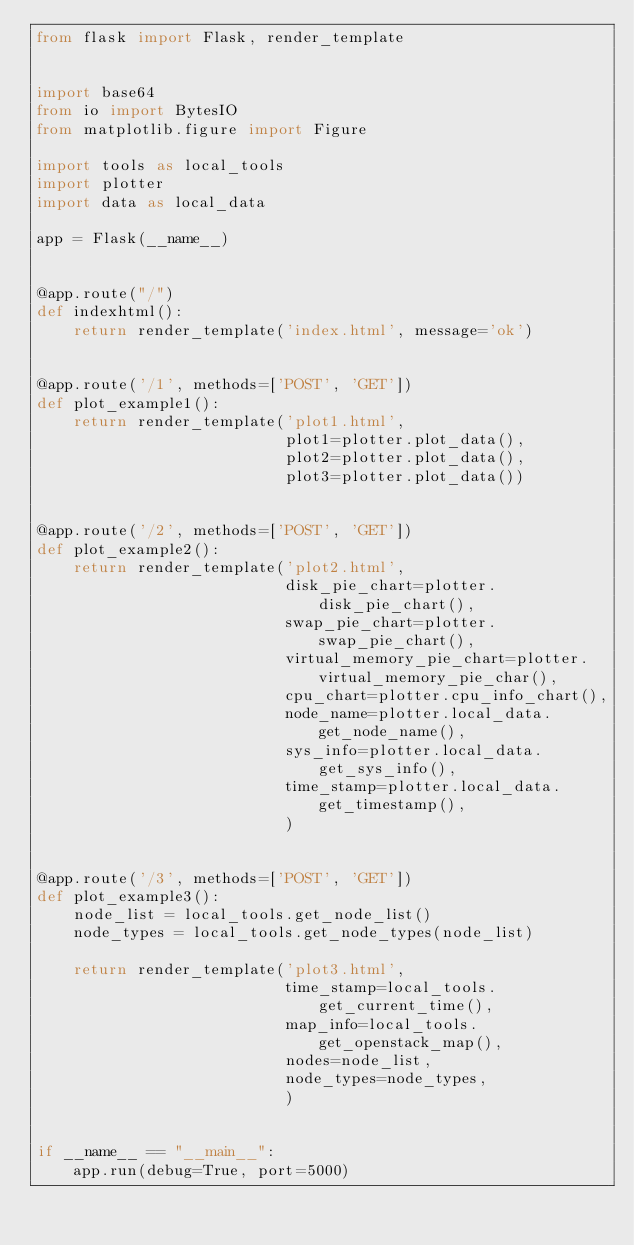<code> <loc_0><loc_0><loc_500><loc_500><_Python_>from flask import Flask, render_template


import base64
from io import BytesIO
from matplotlib.figure import Figure

import tools as local_tools
import plotter
import data as local_data

app = Flask(__name__)


@app.route("/")
def indexhtml():
    return render_template('index.html', message='ok')


@app.route('/1', methods=['POST', 'GET'])
def plot_example1():
    return render_template('plot1.html',
                           plot1=plotter.plot_data(),
                           plot2=plotter.plot_data(),
                           plot3=plotter.plot_data())


@app.route('/2', methods=['POST', 'GET'])
def plot_example2():
    return render_template('plot2.html',
                           disk_pie_chart=plotter.disk_pie_chart(),
                           swap_pie_chart=plotter.swap_pie_chart(),
                           virtual_memory_pie_chart=plotter.virtual_memory_pie_char(),
                           cpu_chart=plotter.cpu_info_chart(),
                           node_name=plotter.local_data.get_node_name(),
                           sys_info=plotter.local_data.get_sys_info(),
                           time_stamp=plotter.local_data.get_timestamp(),
                           )


@app.route('/3', methods=['POST', 'GET'])
def plot_example3():
    node_list = local_tools.get_node_list()
    node_types = local_tools.get_node_types(node_list)

    return render_template('plot3.html',
                           time_stamp=local_tools.get_current_time(),
                           map_info=local_tools.get_openstack_map(),
                           nodes=node_list,
                           node_types=node_types,
                           )


if __name__ == "__main__":
    app.run(debug=True, port=5000)
</code> 